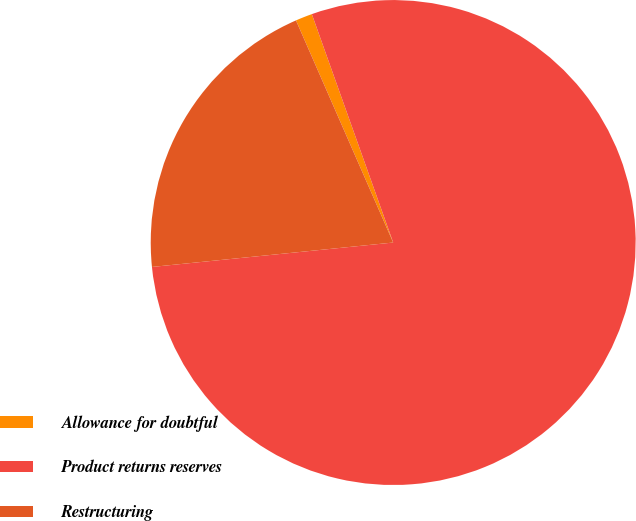Convert chart. <chart><loc_0><loc_0><loc_500><loc_500><pie_chart><fcel>Allowance for doubtful<fcel>Product returns reserves<fcel>Restructuring<nl><fcel>1.12%<fcel>78.84%<fcel>20.04%<nl></chart> 